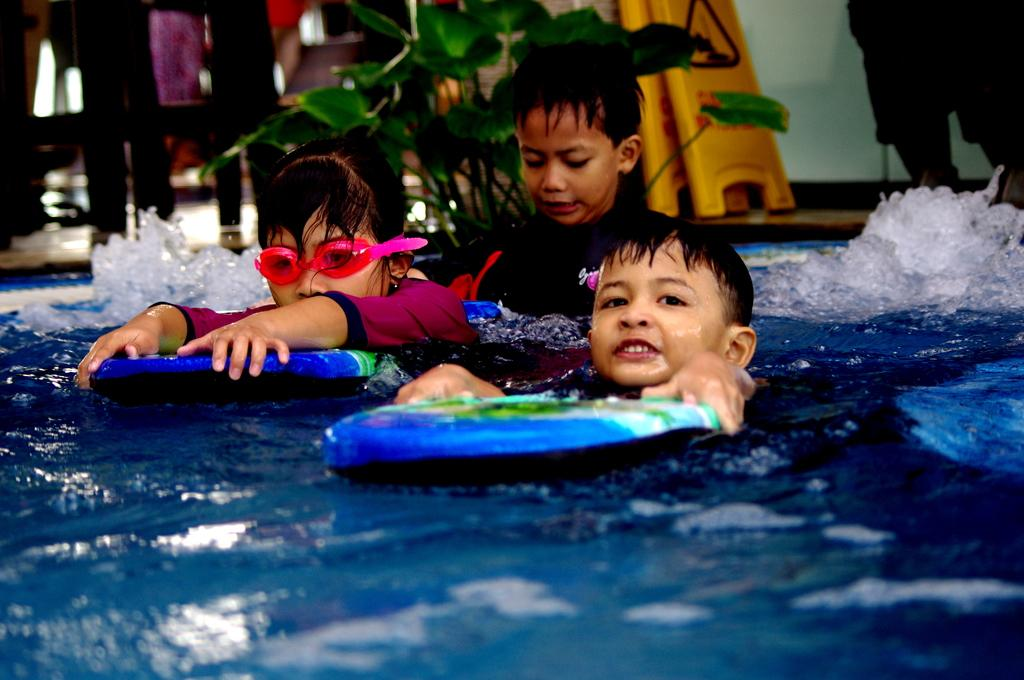What are the three persons in the image doing? The three persons are swimming in the water. Is there anyone else in the image besides the swimmers? Yes, there is a person standing at the back. What type of vegetation can be seen in the image? There is a plant in the image. What object is on the floor in the image? There is a board on the floor. What type of copper material can be seen in the image? There is no copper material present in the image. Are there any trains visible in the image? No, there are no trains visible in the image. 